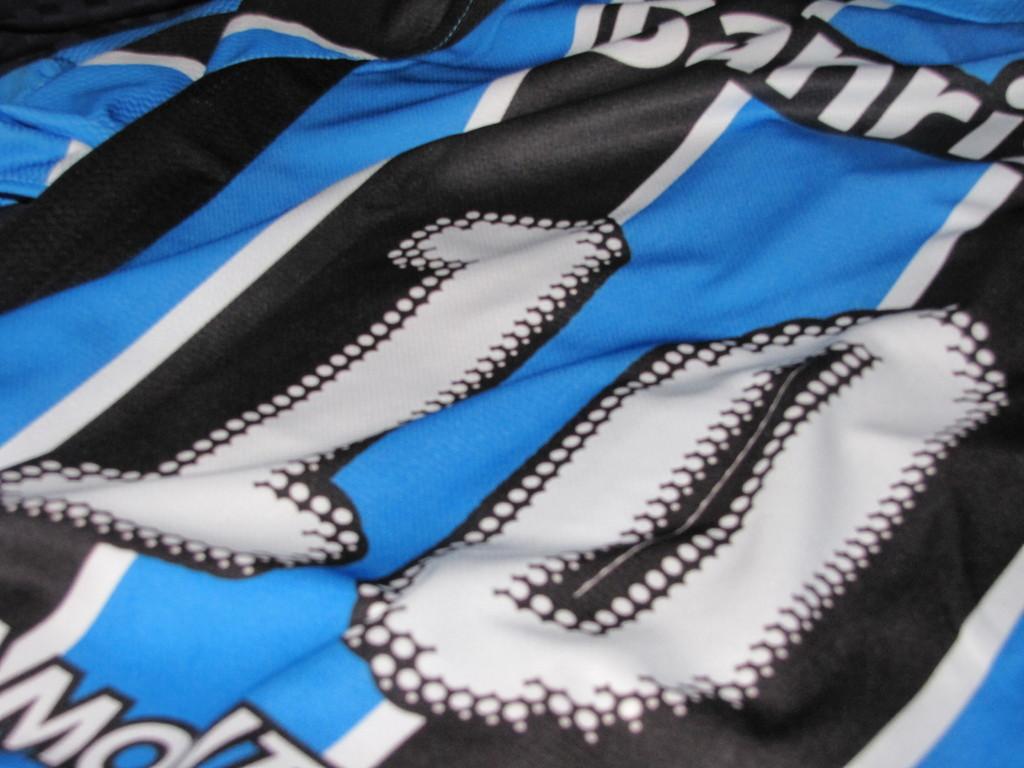What number is on the jersey?
Offer a terse response. 10. What is the first letter seen on the left below the jersey number?
Keep it short and to the point. M. 